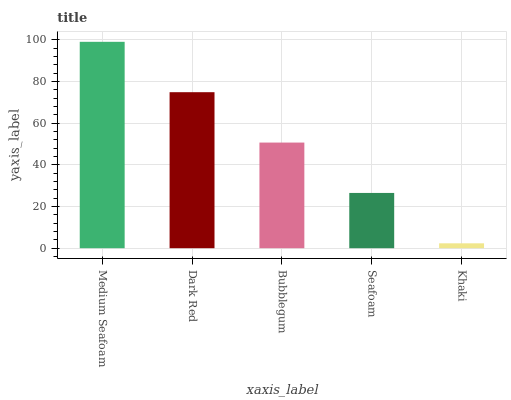Is Khaki the minimum?
Answer yes or no. Yes. Is Medium Seafoam the maximum?
Answer yes or no. Yes. Is Dark Red the minimum?
Answer yes or no. No. Is Dark Red the maximum?
Answer yes or no. No. Is Medium Seafoam greater than Dark Red?
Answer yes or no. Yes. Is Dark Red less than Medium Seafoam?
Answer yes or no. Yes. Is Dark Red greater than Medium Seafoam?
Answer yes or no. No. Is Medium Seafoam less than Dark Red?
Answer yes or no. No. Is Bubblegum the high median?
Answer yes or no. Yes. Is Bubblegum the low median?
Answer yes or no. Yes. Is Seafoam the high median?
Answer yes or no. No. Is Khaki the low median?
Answer yes or no. No. 